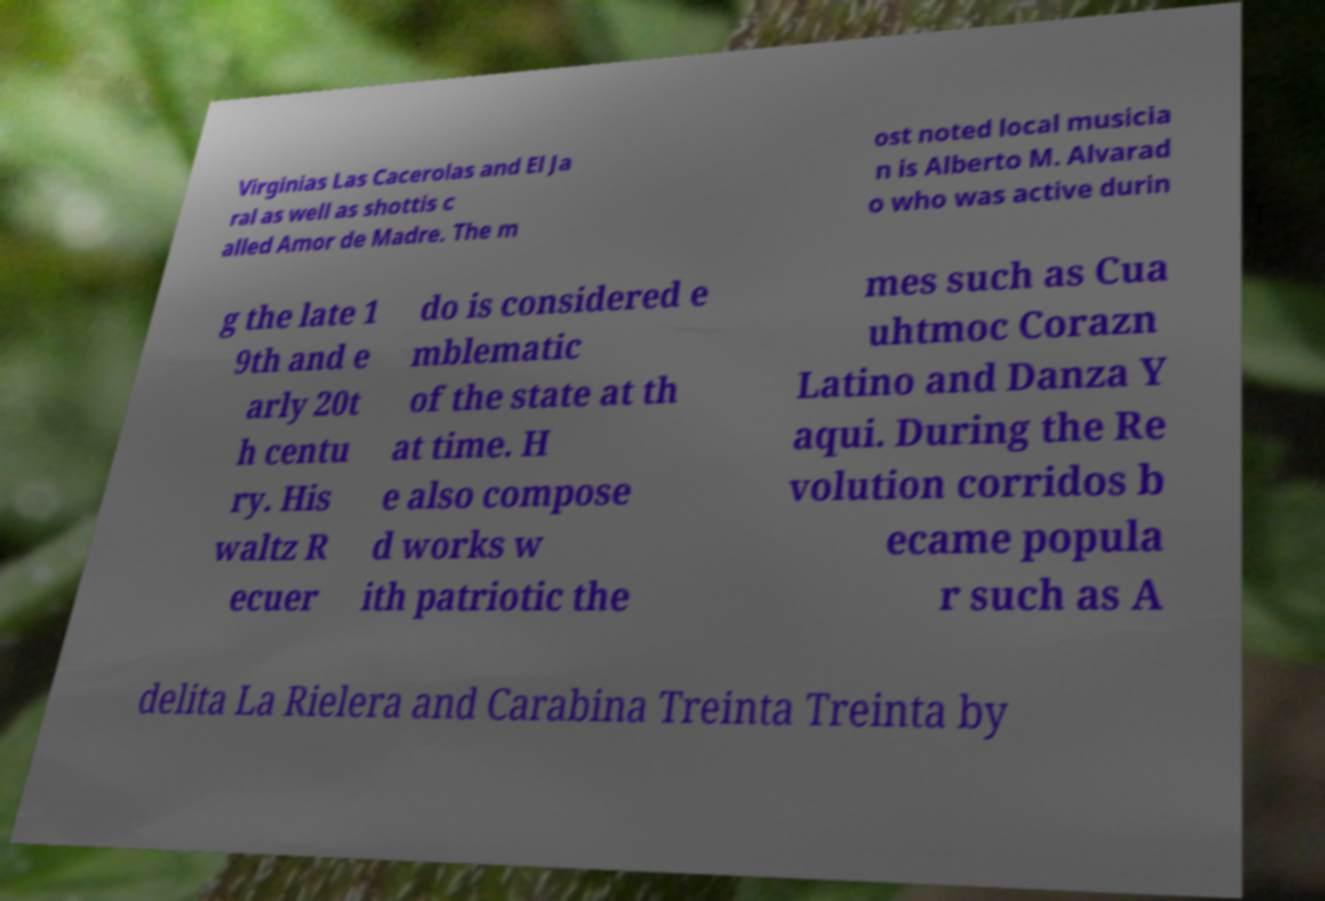There's text embedded in this image that I need extracted. Can you transcribe it verbatim? Virginias Las Cacerolas and El Ja ral as well as shottis c alled Amor de Madre. The m ost noted local musicia n is Alberto M. Alvarad o who was active durin g the late 1 9th and e arly 20t h centu ry. His waltz R ecuer do is considered e mblematic of the state at th at time. H e also compose d works w ith patriotic the mes such as Cua uhtmoc Corazn Latino and Danza Y aqui. During the Re volution corridos b ecame popula r such as A delita La Rielera and Carabina Treinta Treinta by 